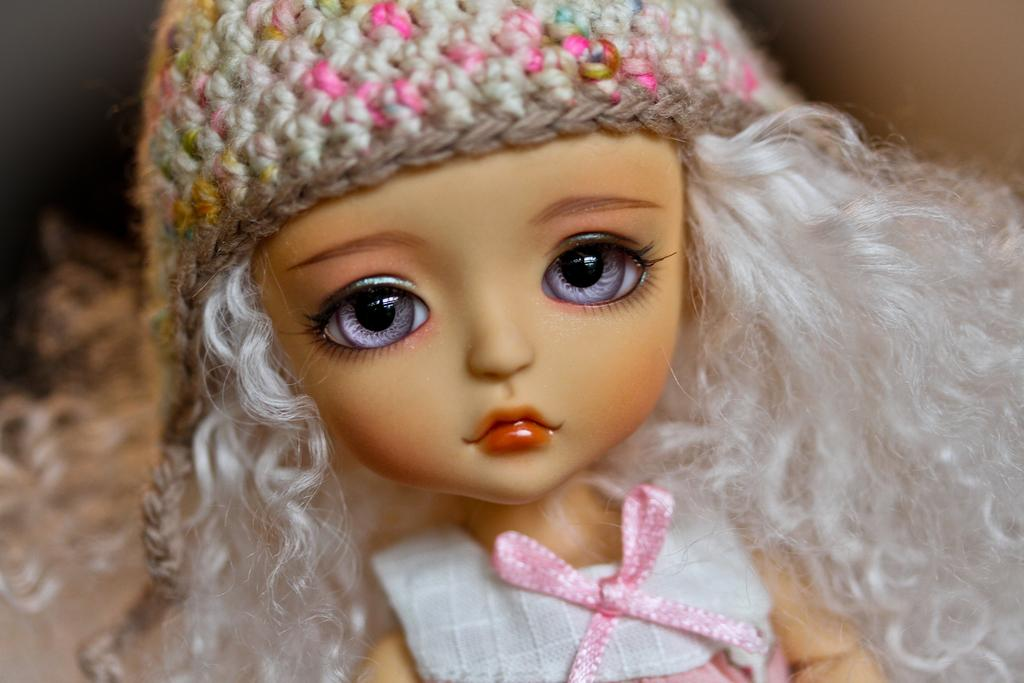What is the main subject of the image? There is a doll in the image. What is the doll wearing on its head? The doll is wearing a hat. How many cushions are present on the seashore in the image? There is no seashore or cushions present in the image; it features a doll wearing a hat. 